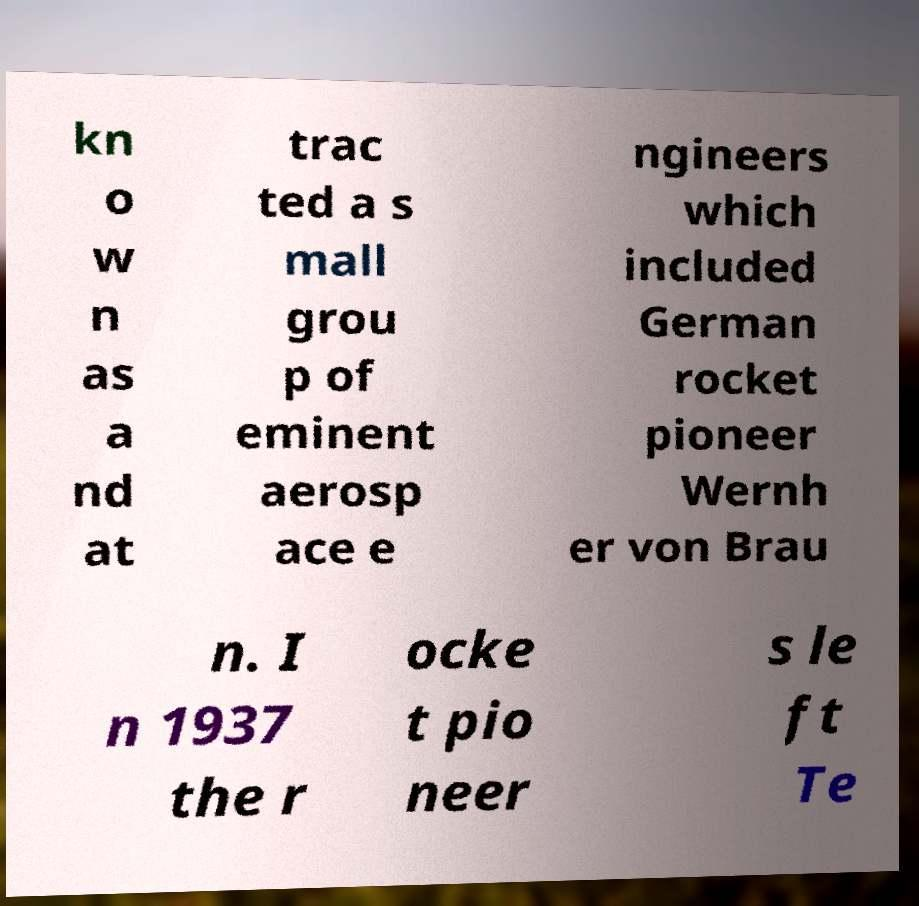Please read and relay the text visible in this image. What does it say? kn o w n as a nd at trac ted a s mall grou p of eminent aerosp ace e ngineers which included German rocket pioneer Wernh er von Brau n. I n 1937 the r ocke t pio neer s le ft Te 